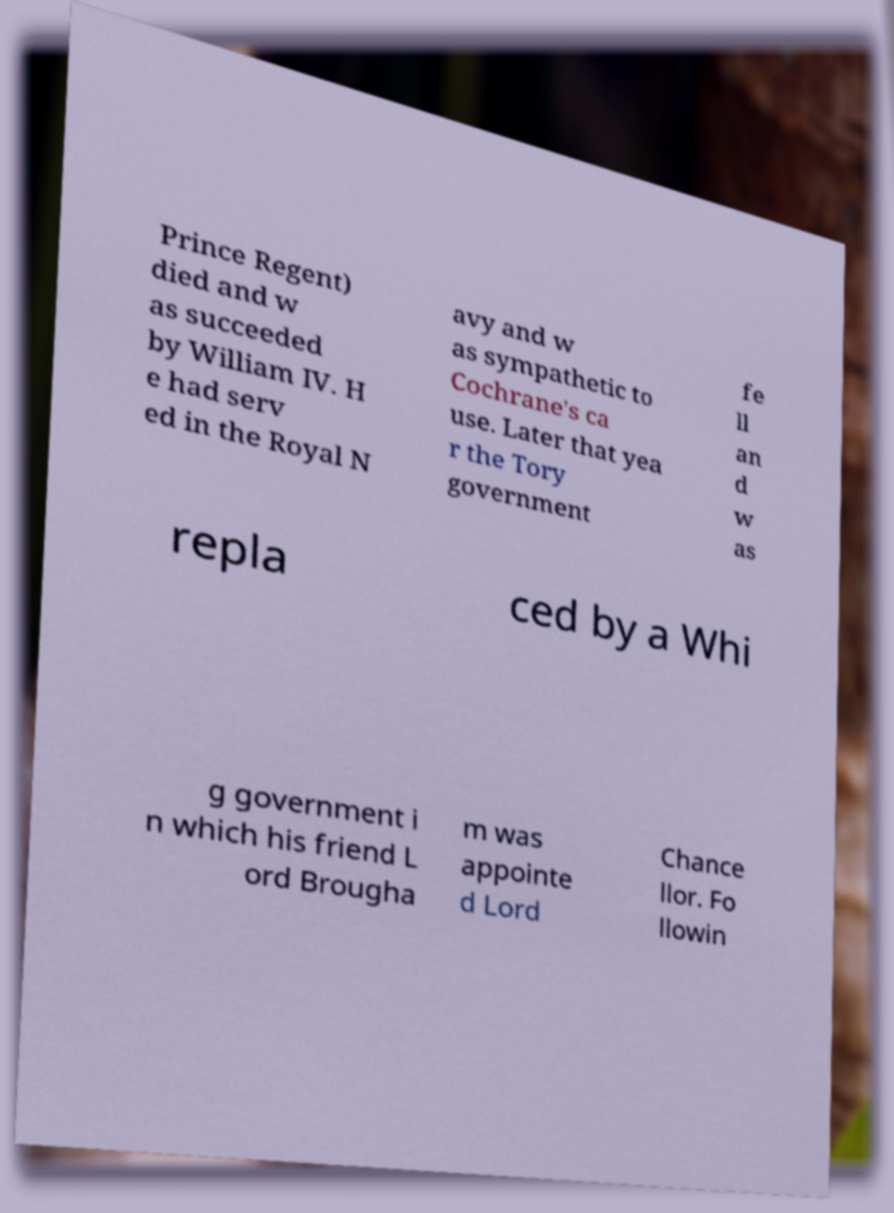There's text embedded in this image that I need extracted. Can you transcribe it verbatim? Prince Regent) died and w as succeeded by William IV. H e had serv ed in the Royal N avy and w as sympathetic to Cochrane's ca use. Later that yea r the Tory government fe ll an d w as repla ced by a Whi g government i n which his friend L ord Brougha m was appointe d Lord Chance llor. Fo llowin 